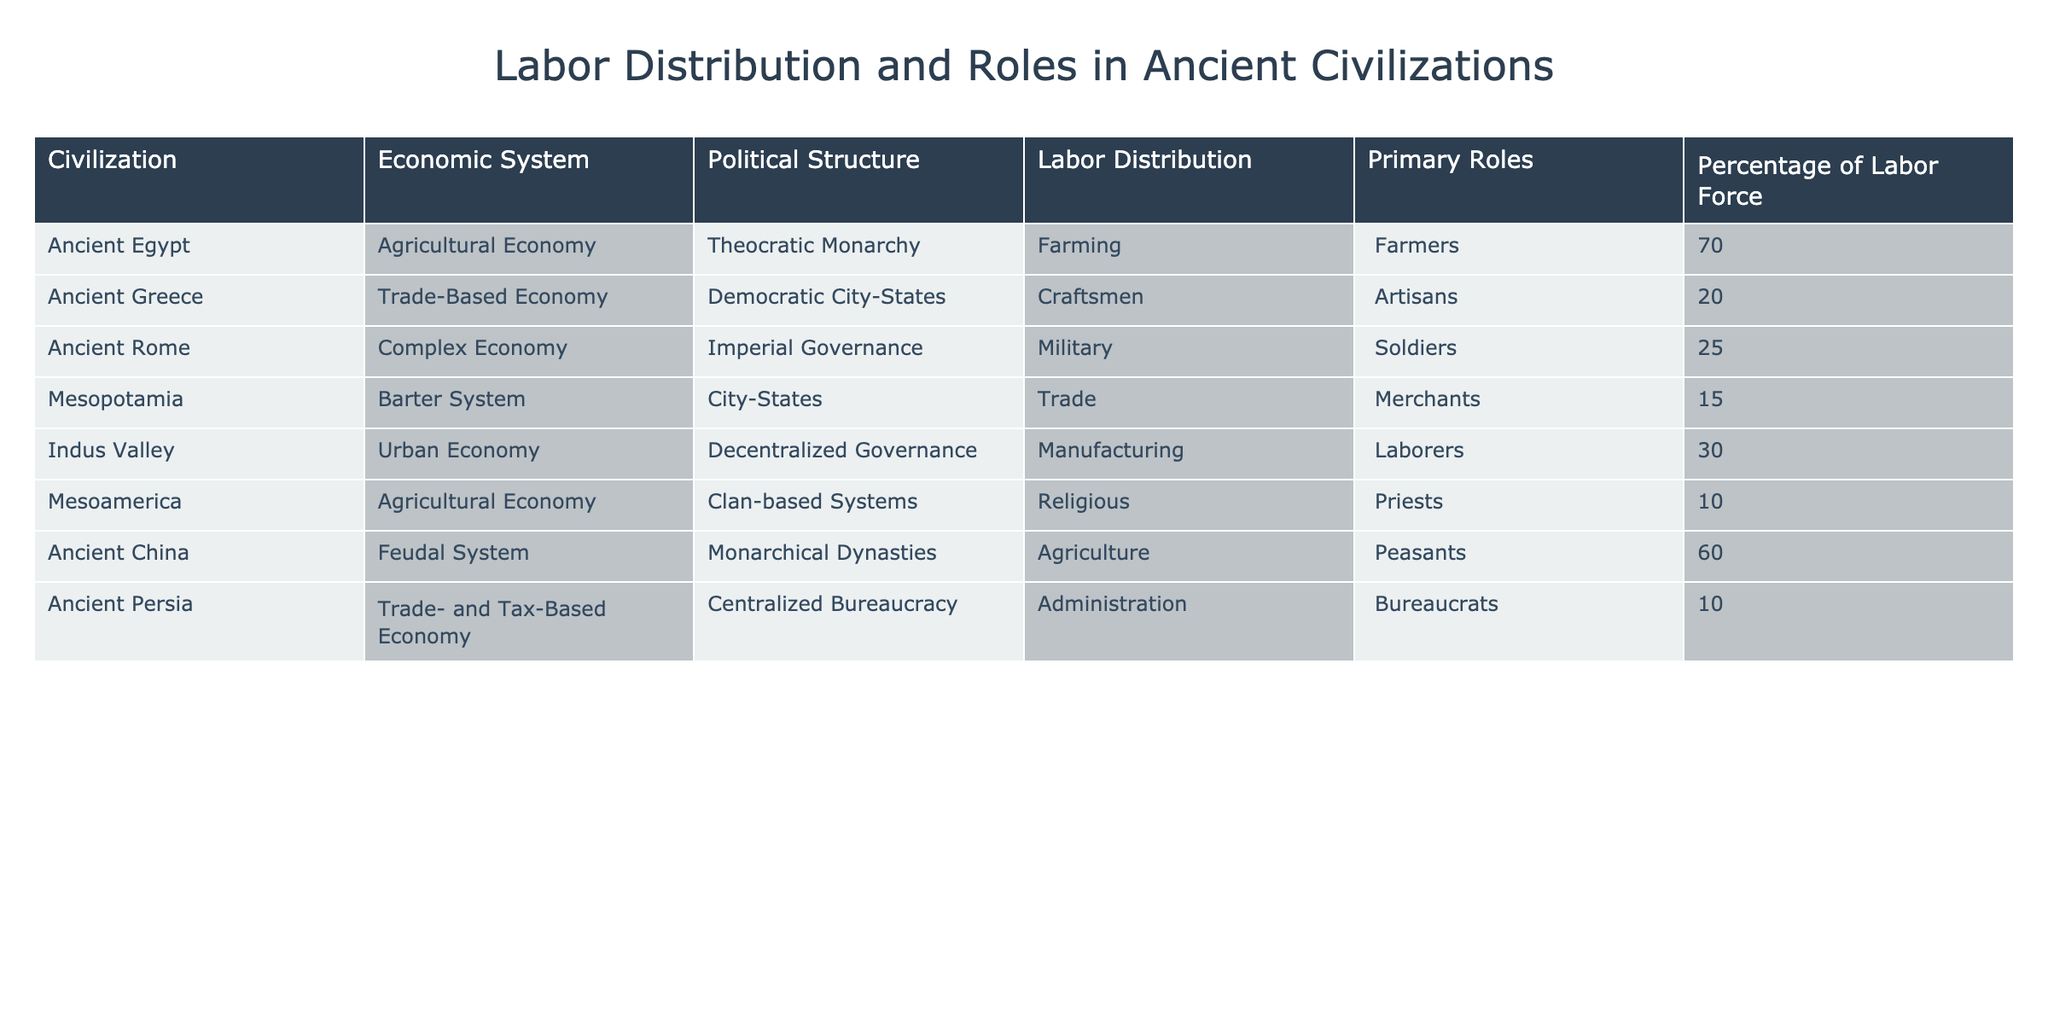What percentage of the labor force in Ancient Egypt was involved in farming? Referring to the table, under the "Labor Distribution" column for Ancient Egypt, it shows that 70% of the labor force was involved in farming.
Answer: 70% Which civilization had the highest percentage of its labor force engaged in agriculture? By examining the table, Ancient Egypt shows the highest percentage, with 70% of its labor force engaged in farming, compared to other civilizations.
Answer: Ancient Egypt What is the total percentage of the labor force engaged in military roles across the listed civilizations? We need to identify those civilizations with military roles: Ancient Rome has 25% (Soldiers) and no other civilizations listed under military roles. Thus, total military engagement is 25%.
Answer: 25% Is it true that all civilizations listed employed a percentage of their labor force in agriculture? Checking the table, Ancient Greece has 20% in craftsmen, Ancient Persia has 10% in administration roles, and Mesoamerica lists priests. Therefore, not all civilizations employed a percentage in agriculture.
Answer: No What is the average percentage of the labor force in trade-related roles across the listed civilizations? Calculating the percentage of labor involved in trade-related roles: Ancient Greece (20% Craftsmen), Mesopotamia (15% Merchants), Ancient Persia (10% Bureaucrats), adding them gives 20 + 15 + 10 = 45. There are 3 civilizations, so the average is 45 / 3 = 15%.
Answer: 15% How does the labor distribution in Ancient China compare to that in Mesoamerica and Ancient Greece? In the table, Ancient China has 60% in agriculture (Peasants), Mesoamerica has 10% in religious roles (Priests), and Ancient Greece has 20% in craftsmen (Artisans). Comparing these shows Ancient China has significantly more labor engaged in agriculture than the other two.
Answer: Ancient China has the most Which economic system has the least percentage of its labor force engaged in any role related to agriculture? Looking at the labor distribution of the civilizations, Ancient Greece (20% Craftsmen), Mesoamerica (10% Religious), and Ancient Persia (10% Administration) show low engagement in agriculture. The least is Mesoamerica with only 10% in religious roles with no agricultural labor involvement mentioned.
Answer: Mesoamerica What is the difference in percentage between the labor distribution of craftsmen in Ancient Greece and trade in Mesopotamia? According to the table, Ancient Greece has 20% craftsmen, while Mesopotamia has 15% involved in trade. The difference is 20 - 15 = 5%.
Answer: 5% 